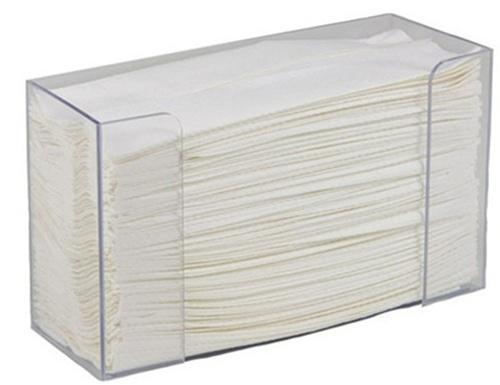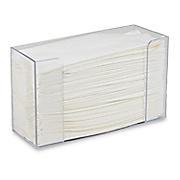The first image is the image on the left, the second image is the image on the right. Analyze the images presented: Is the assertion "There is not paper visible in the grey dispenser in the right." valid? Answer yes or no. No. The first image is the image on the left, the second image is the image on the right. Analyze the images presented: Is the assertion "At least one image shows exactly one clear rectangular tray-like container of folded paper towels." valid? Answer yes or no. Yes. 